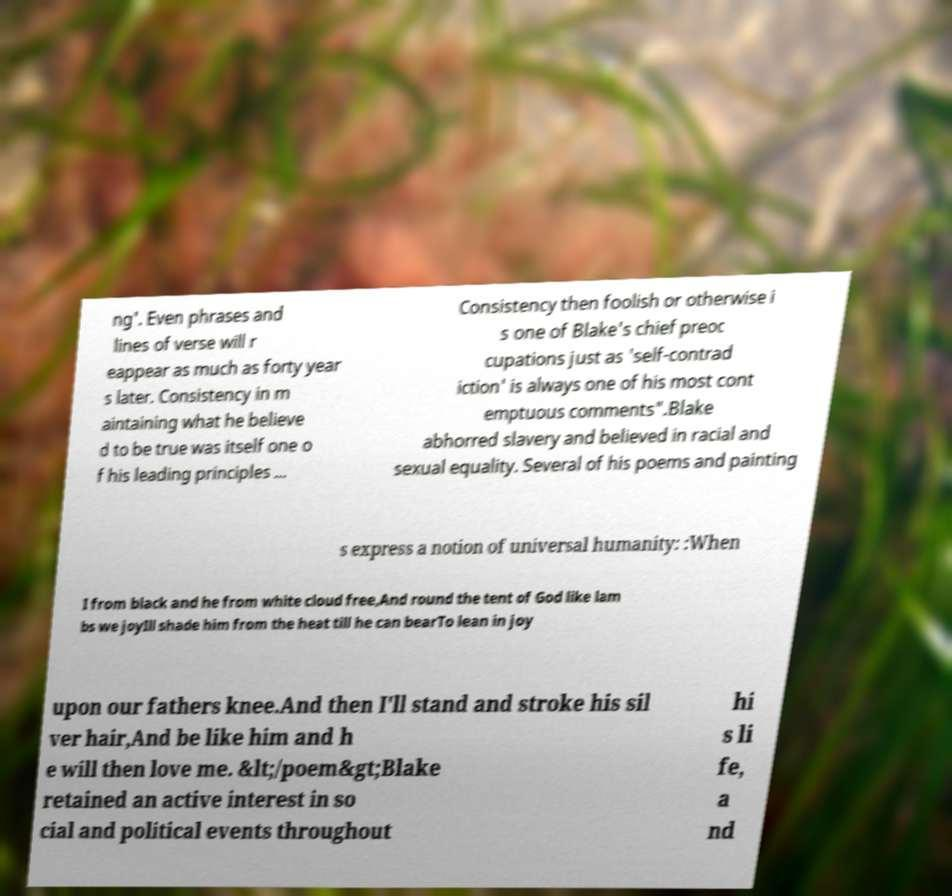There's text embedded in this image that I need extracted. Can you transcribe it verbatim? ng'. Even phrases and lines of verse will r eappear as much as forty year s later. Consistency in m aintaining what he believe d to be true was itself one o f his leading principles ... Consistency then foolish or otherwise i s one of Blake's chief preoc cupations just as 'self-contrad iction' is always one of his most cont emptuous comments".Blake abhorred slavery and believed in racial and sexual equality. Several of his poems and painting s express a notion of universal humanity: :When I from black and he from white cloud free,And round the tent of God like lam bs we joyIll shade him from the heat till he can bearTo lean in joy upon our fathers knee.And then I'll stand and stroke his sil ver hair,And be like him and h e will then love me. &lt;/poem&gt;Blake retained an active interest in so cial and political events throughout hi s li fe, a nd 